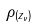Convert formula to latex. <formula><loc_0><loc_0><loc_500><loc_500>\rho _ { ( z _ { \nu } ) }</formula> 